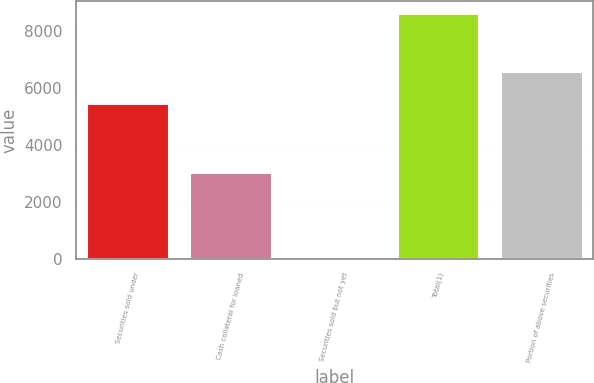Convert chart. <chart><loc_0><loc_0><loc_500><loc_500><bar_chart><fcel>Securities sold under<fcel>Cash collateral for loaned<fcel>Securities sold but not yet<fcel>Total(1)<fcel>Portion of above securities<nl><fcel>5492<fcel>3064<fcel>77<fcel>8633<fcel>6610<nl></chart> 